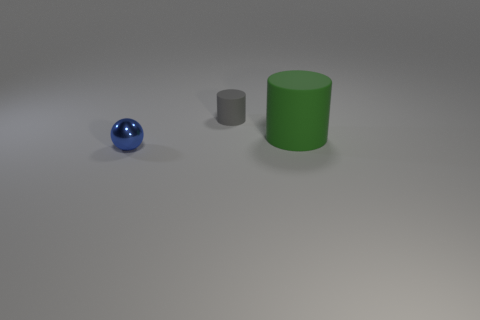Add 1 big objects. How many objects exist? 4 Subtract 1 cylinders. How many cylinders are left? 1 Subtract all green cylinders. How many cylinders are left? 1 Subtract all balls. How many objects are left? 2 Add 2 tiny gray cylinders. How many tiny gray cylinders exist? 3 Subtract 0 gray spheres. How many objects are left? 3 Subtract all yellow cylinders. Subtract all blue cubes. How many cylinders are left? 2 Subtract all cyan spheres. How many brown cylinders are left? 0 Subtract all yellow rubber spheres. Subtract all matte cylinders. How many objects are left? 1 Add 3 small balls. How many small balls are left? 4 